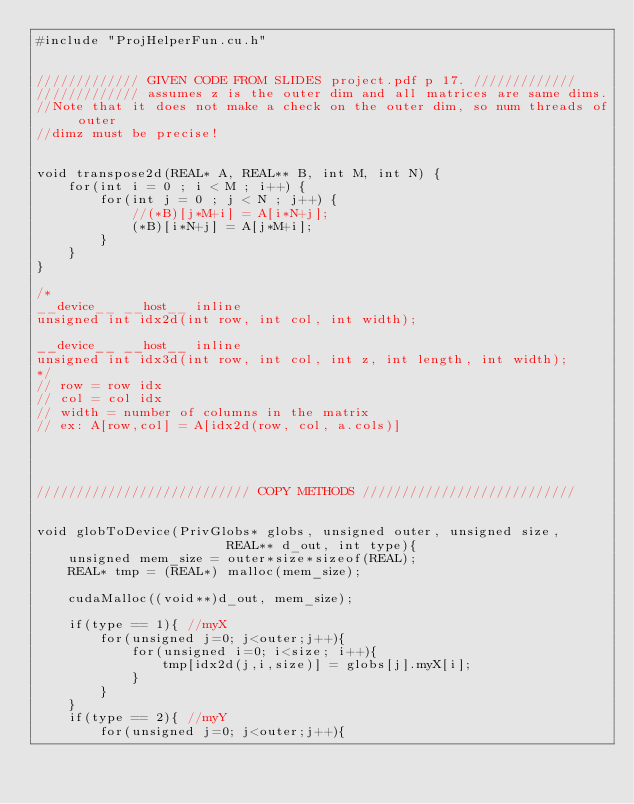<code> <loc_0><loc_0><loc_500><loc_500><_Cuda_>#include "ProjHelperFun.cu.h"


///////////// GIVEN CODE FROM SLIDES project.pdf p 17. /////////////
///////////// assumes z is the outer dim and all matrices are same dims.
//Note that it does not make a check on the outer dim, so num threads of outer 
//dimz must be precise!


void transpose2d(REAL* A, REAL** B, int M, int N) {
    for(int i = 0 ; i < M ; i++) {
        for(int j = 0 ; j < N ; j++) {
            //(*B)[j*M+i] = A[i*N+j];
            (*B)[i*N+j] = A[j*M+i];
        }
    }
}

/*
__device__ __host__ inline 
unsigned int idx2d(int row, int col, int width);

__device__ __host__ inline 
unsigned int idx3d(int row, int col, int z, int length, int width);
*/
// row = row idx
// col = col idx
// width = number of columns in the matrix
// ex: A[row,col] = A[idx2d(row, col, a.cols)]




/////////////////////////// COPY METHODS ///////////////////////////


void globToDevice(PrivGlobs* globs, unsigned outer, unsigned size, 
                        REAL** d_out, int type){
    unsigned mem_size = outer*size*sizeof(REAL);
    REAL* tmp = (REAL*) malloc(mem_size);

    cudaMalloc((void**)d_out, mem_size);
    
    if(type == 1){ //myX
        for(unsigned j=0; j<outer;j++){
            for(unsigned i=0; i<size; i++){
                tmp[idx2d(j,i,size)] = globs[j].myX[i];
            }
        }
    }
    if(type == 2){ //myY
        for(unsigned j=0; j<outer;j++){</code> 